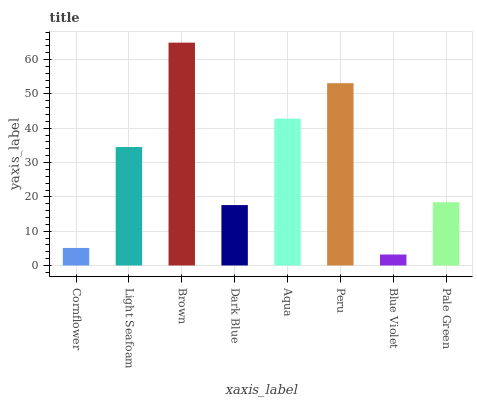Is Brown the maximum?
Answer yes or no. Yes. Is Light Seafoam the minimum?
Answer yes or no. No. Is Light Seafoam the maximum?
Answer yes or no. No. Is Light Seafoam greater than Cornflower?
Answer yes or no. Yes. Is Cornflower less than Light Seafoam?
Answer yes or no. Yes. Is Cornflower greater than Light Seafoam?
Answer yes or no. No. Is Light Seafoam less than Cornflower?
Answer yes or no. No. Is Light Seafoam the high median?
Answer yes or no. Yes. Is Pale Green the low median?
Answer yes or no. Yes. Is Blue Violet the high median?
Answer yes or no. No. Is Blue Violet the low median?
Answer yes or no. No. 